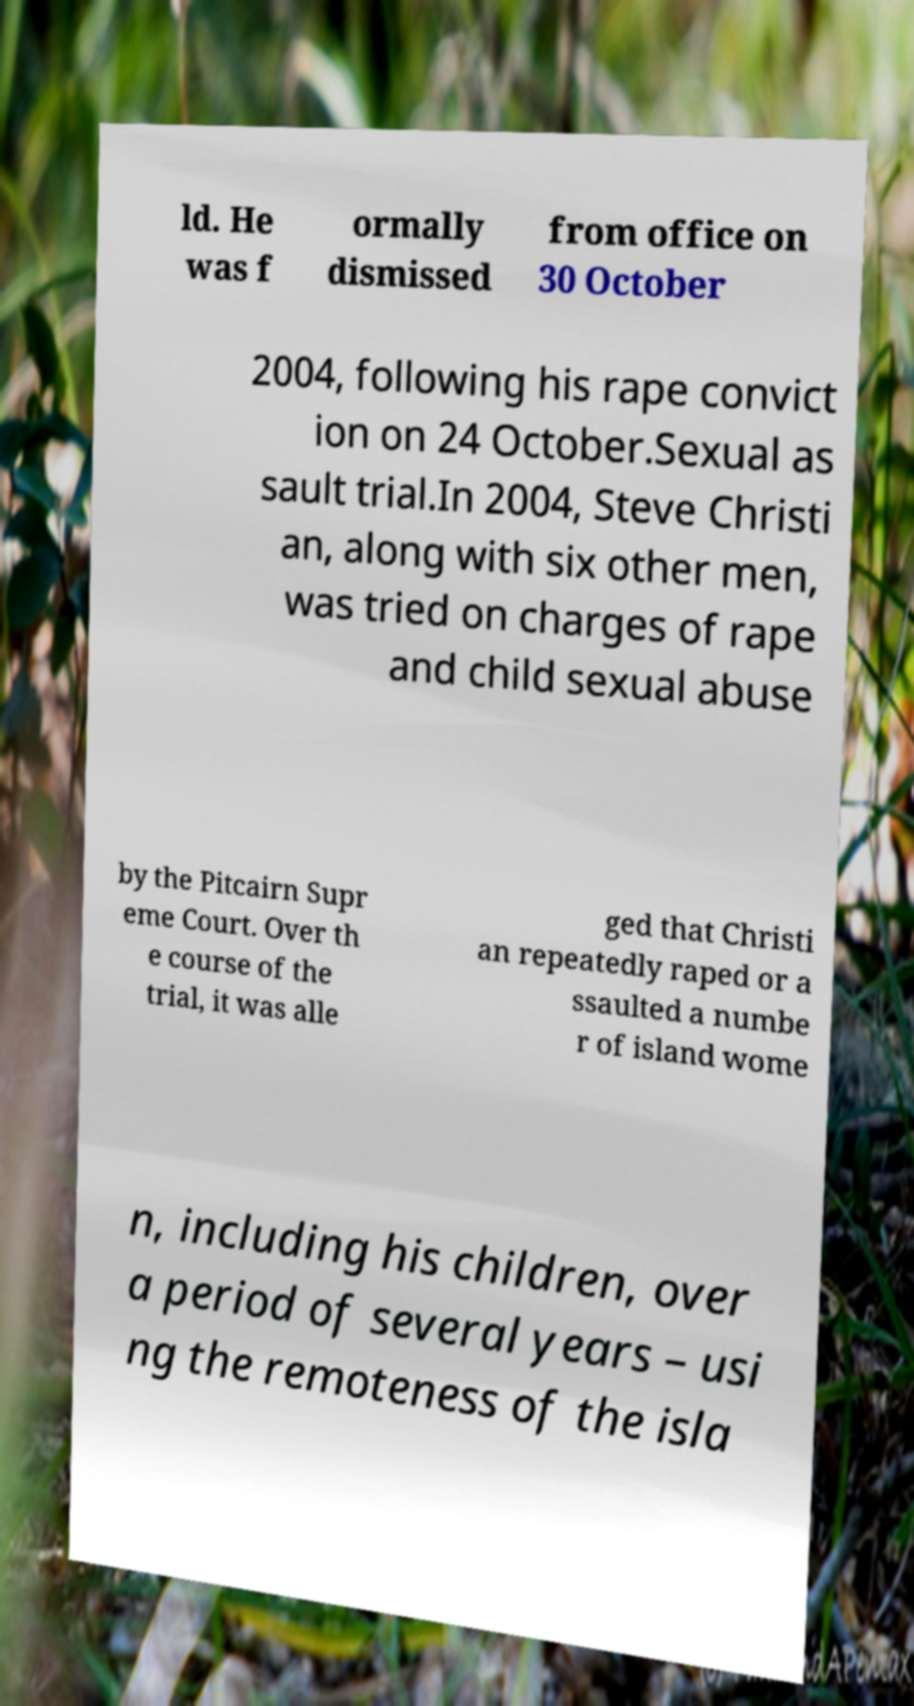Could you extract and type out the text from this image? ld. He was f ormally dismissed from office on 30 October 2004, following his rape convict ion on 24 October.Sexual as sault trial.In 2004, Steve Christi an, along with six other men, was tried on charges of rape and child sexual abuse by the Pitcairn Supr eme Court. Over th e course of the trial, it was alle ged that Christi an repeatedly raped or a ssaulted a numbe r of island wome n, including his children, over a period of several years – usi ng the remoteness of the isla 